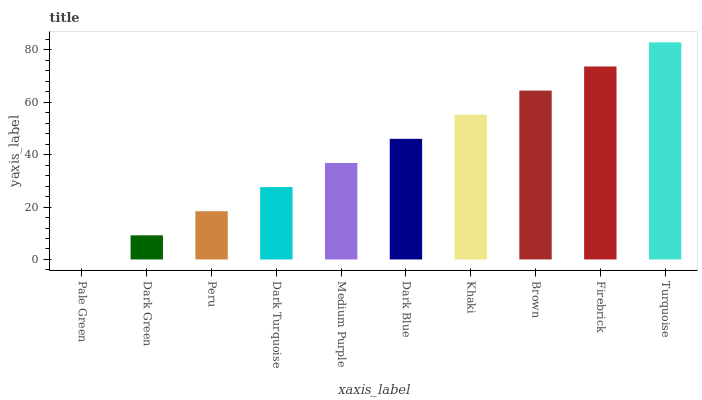Is Pale Green the minimum?
Answer yes or no. Yes. Is Turquoise the maximum?
Answer yes or no. Yes. Is Dark Green the minimum?
Answer yes or no. No. Is Dark Green the maximum?
Answer yes or no. No. Is Dark Green greater than Pale Green?
Answer yes or no. Yes. Is Pale Green less than Dark Green?
Answer yes or no. Yes. Is Pale Green greater than Dark Green?
Answer yes or no. No. Is Dark Green less than Pale Green?
Answer yes or no. No. Is Dark Blue the high median?
Answer yes or no. Yes. Is Medium Purple the low median?
Answer yes or no. Yes. Is Turquoise the high median?
Answer yes or no. No. Is Firebrick the low median?
Answer yes or no. No. 